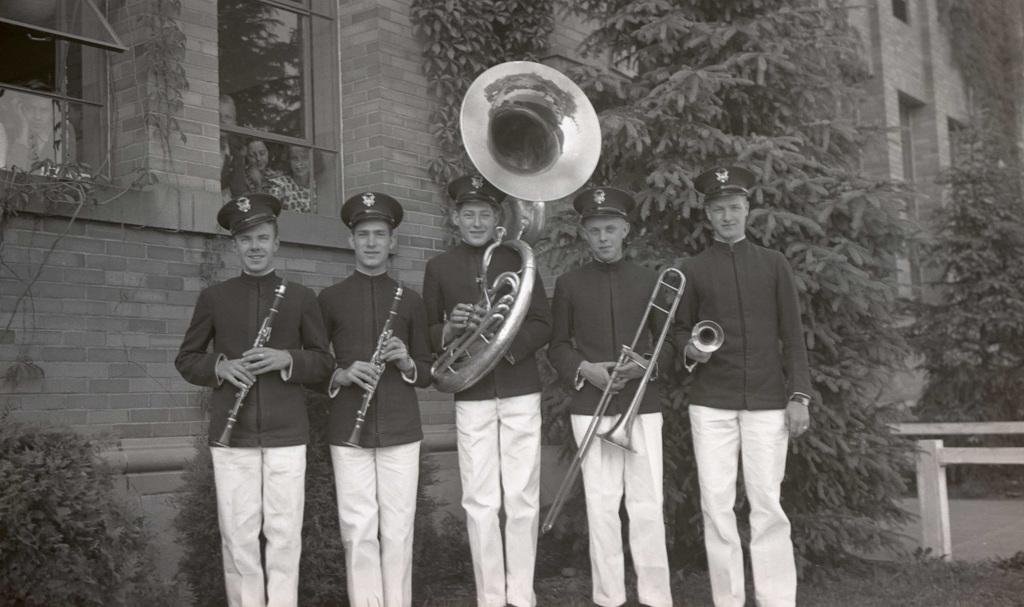What are the people in the image doing? The people in the image are holding musical instruments. Can you describe the people in the background of the image? There are people in the background of the image, but no specific details are provided. What can be seen in the background of the image? There is a building and trees in the background of the image. What type of cough can be heard from the people in the image? There is no mention of any cough or sound in the image, so it cannot be determined. 